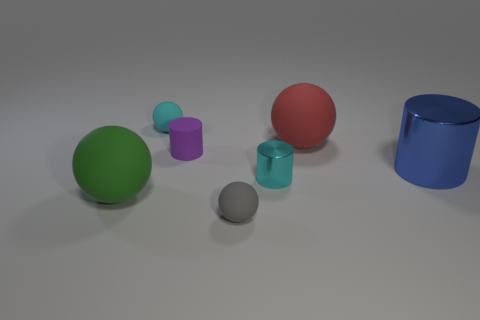Is there a tiny gray object made of the same material as the big blue thing?
Provide a succinct answer. No. How many green things are either balls or metallic objects?
Offer a very short reply. 1. There is a rubber sphere that is both on the left side of the gray matte sphere and to the right of the green rubber ball; how big is it?
Give a very brief answer. Small. Is the number of small rubber cylinders in front of the large blue shiny object greater than the number of brown metallic things?
Keep it short and to the point. No. What number of blocks are either tiny blue objects or gray objects?
Offer a very short reply. 0. There is a big object that is in front of the big red ball and to the right of the tiny purple rubber thing; what is its shape?
Your response must be concise. Cylinder. Is the number of purple things left of the large blue shiny cylinder the same as the number of shiny things that are left of the small purple rubber cylinder?
Provide a succinct answer. No. What number of things are either big green matte balls or red objects?
Provide a succinct answer. 2. There is a metal object that is the same size as the gray rubber object; what is its color?
Your answer should be very brief. Cyan. How many things are either green objects in front of the big blue metallic object or balls in front of the green thing?
Offer a terse response. 2. 